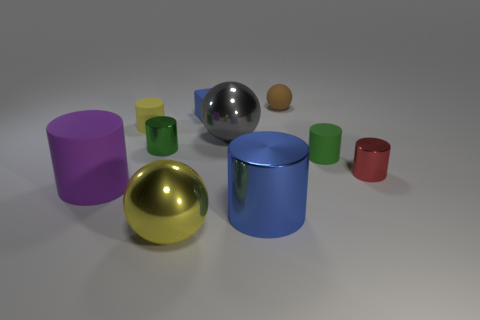What material is the big purple object that is the same shape as the large blue thing?
Offer a very short reply. Rubber. What number of red things are rubber objects or cubes?
Make the answer very short. 0. What is the material of the green cylinder left of the tiny brown object?
Offer a very short reply. Metal. Are there more big green metal balls than large things?
Your response must be concise. No. There is a green object that is on the right side of the tiny brown matte object; does it have the same shape as the purple thing?
Keep it short and to the point. Yes. How many balls are in front of the tiny rubber sphere and behind the small blue block?
Your response must be concise. 0. How many tiny matte objects have the same shape as the gray shiny object?
Provide a short and direct response. 1. The ball right of the blue metal cylinder that is in front of the small yellow object is what color?
Give a very brief answer. Brown. Is the shape of the large purple rubber object the same as the small metal thing that is to the right of the big blue metal object?
Make the answer very short. Yes. What material is the large object behind the purple cylinder that is to the left of the matte cylinder behind the small green shiny object made of?
Give a very brief answer. Metal. 